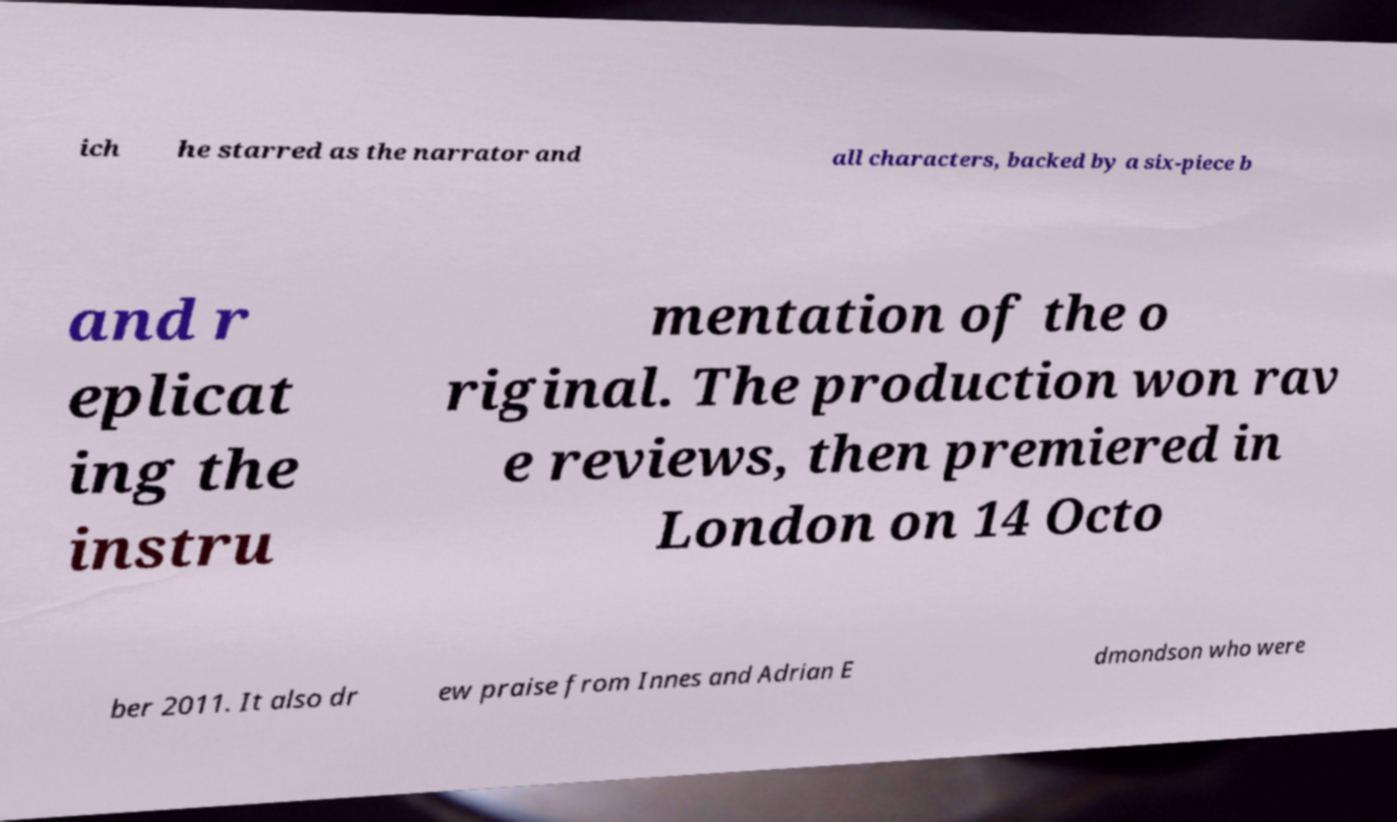What messages or text are displayed in this image? I need them in a readable, typed format. ich he starred as the narrator and all characters, backed by a six-piece b and r eplicat ing the instru mentation of the o riginal. The production won rav e reviews, then premiered in London on 14 Octo ber 2011. It also dr ew praise from Innes and Adrian E dmondson who were 